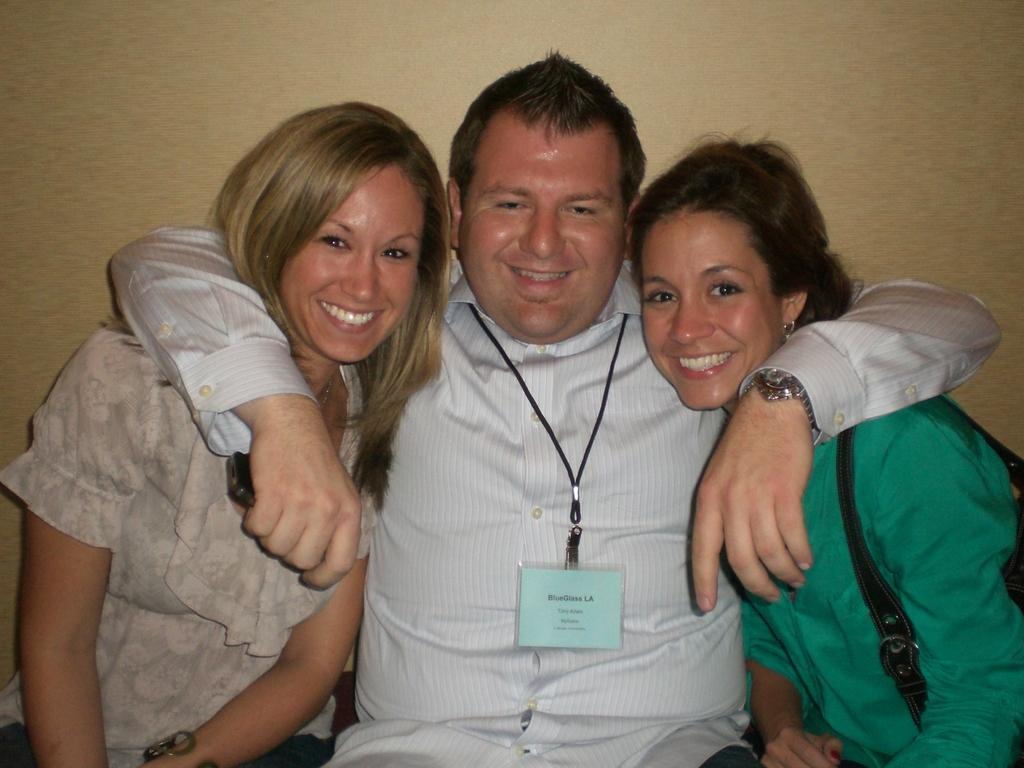Please provide a concise description of this image. In this image I can see a man is sitting by placing his hands on the women. He wore an Id card, shirt, watch, two women are there on either side of him. Behind him there is the wall. 